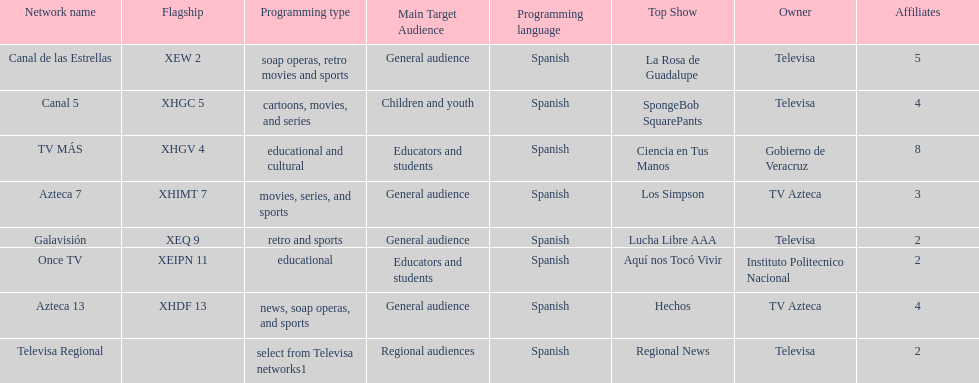Name each of tv azteca's network names. Azteca 7, Azteca 13. 